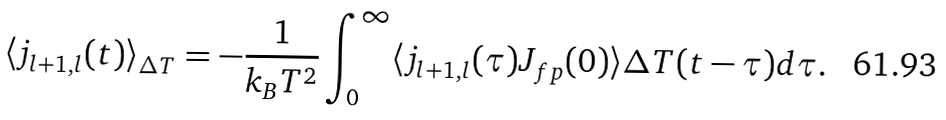<formula> <loc_0><loc_0><loc_500><loc_500>\langle j _ { l + 1 , l } ( t ) \rangle _ { \Delta T } = - \frac { 1 } { k _ { B } T ^ { 2 } } \int _ { 0 } ^ { \infty } \langle j _ { l + 1 , l } ( \tau ) J _ { f p } ( 0 ) \rangle \Delta T ( t - \tau ) d \tau .</formula> 